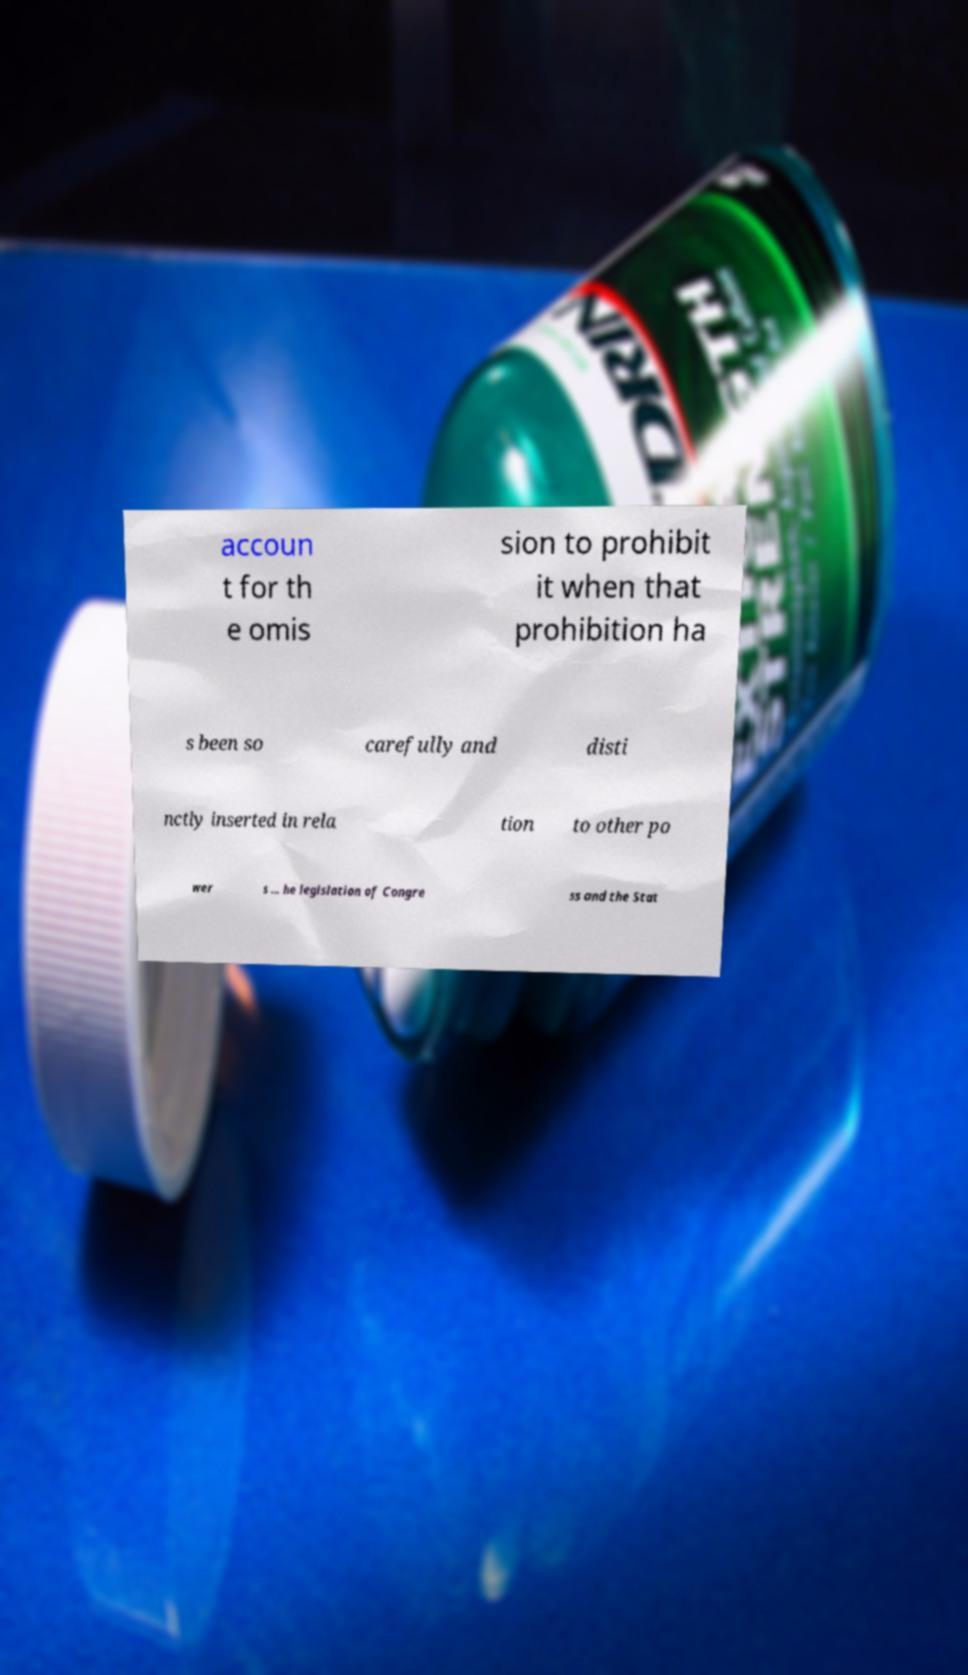Could you extract and type out the text from this image? accoun t for th e omis sion to prohibit it when that prohibition ha s been so carefully and disti nctly inserted in rela tion to other po wer s ... he legislation of Congre ss and the Stat 